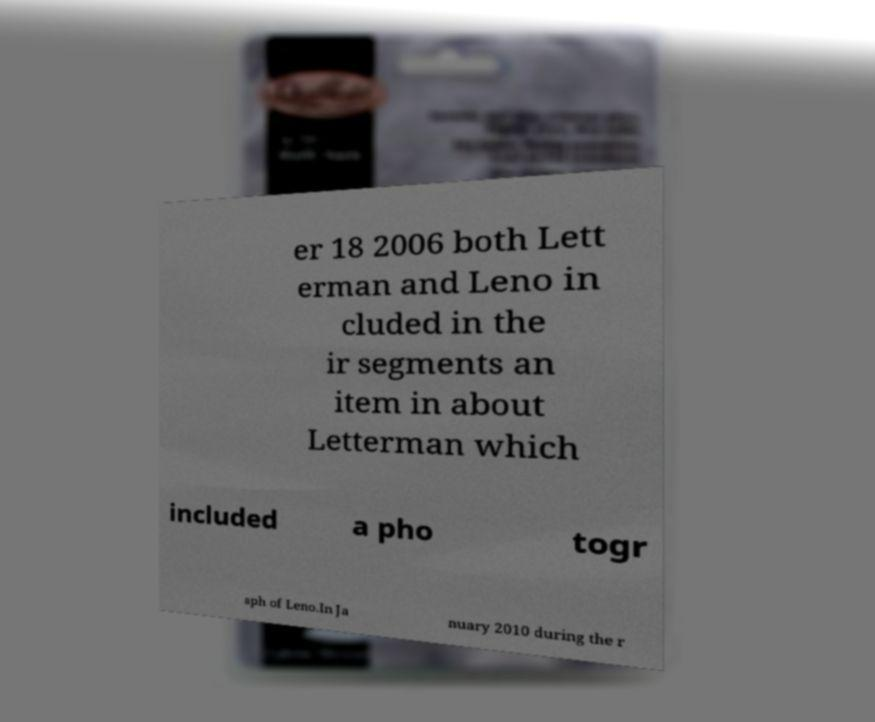What messages or text are displayed in this image? I need them in a readable, typed format. er 18 2006 both Lett erman and Leno in cluded in the ir segments an item in about Letterman which included a pho togr aph of Leno.In Ja nuary 2010 during the r 